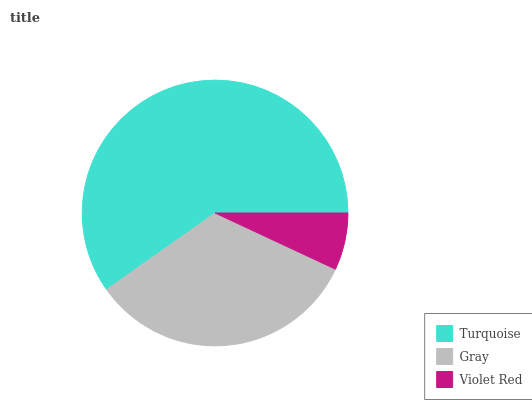Is Violet Red the minimum?
Answer yes or no. Yes. Is Turquoise the maximum?
Answer yes or no. Yes. Is Gray the minimum?
Answer yes or no. No. Is Gray the maximum?
Answer yes or no. No. Is Turquoise greater than Gray?
Answer yes or no. Yes. Is Gray less than Turquoise?
Answer yes or no. Yes. Is Gray greater than Turquoise?
Answer yes or no. No. Is Turquoise less than Gray?
Answer yes or no. No. Is Gray the high median?
Answer yes or no. Yes. Is Gray the low median?
Answer yes or no. Yes. Is Turquoise the high median?
Answer yes or no. No. Is Violet Red the low median?
Answer yes or no. No. 